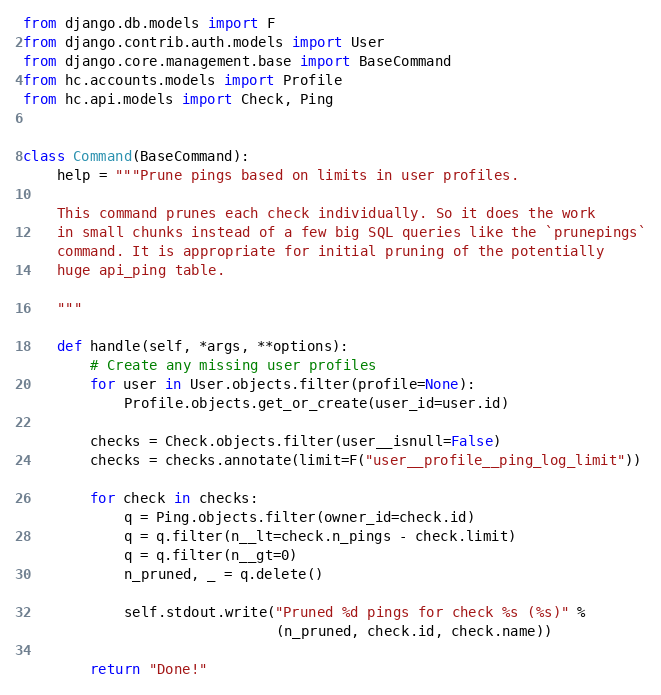<code> <loc_0><loc_0><loc_500><loc_500><_Python_>from django.db.models import F
from django.contrib.auth.models import User
from django.core.management.base import BaseCommand
from hc.accounts.models import Profile
from hc.api.models import Check, Ping


class Command(BaseCommand):
    help = """Prune pings based on limits in user profiles.

    This command prunes each check individually. So it does the work
    in small chunks instead of a few big SQL queries like the `prunepings`
    command. It is appropriate for initial pruning of the potentially
    huge api_ping table.

    """

    def handle(self, *args, **options):
        # Create any missing user profiles
        for user in User.objects.filter(profile=None):
            Profile.objects.get_or_create(user_id=user.id)

        checks = Check.objects.filter(user__isnull=False)
        checks = checks.annotate(limit=F("user__profile__ping_log_limit"))

        for check in checks:
            q = Ping.objects.filter(owner_id=check.id)
            q = q.filter(n__lt=check.n_pings - check.limit)
            q = q.filter(n__gt=0)
            n_pruned, _ = q.delete()

            self.stdout.write("Pruned %d pings for check %s (%s)" %
                              (n_pruned, check.id, check.name))

        return "Done!"
</code> 